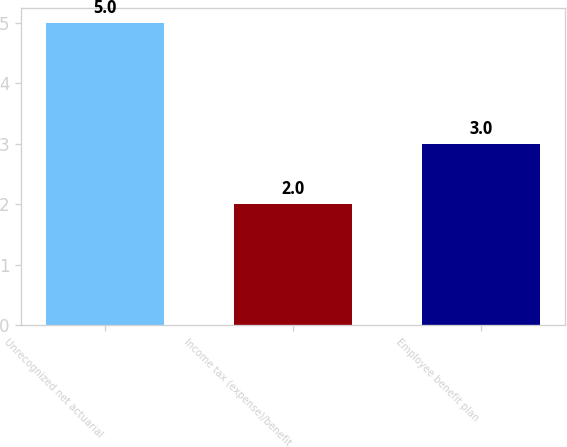Convert chart. <chart><loc_0><loc_0><loc_500><loc_500><bar_chart><fcel>Unrecognized net actuarial<fcel>Income tax (expense)/benefit<fcel>Employee benefit plan<nl><fcel>5<fcel>2<fcel>3<nl></chart> 